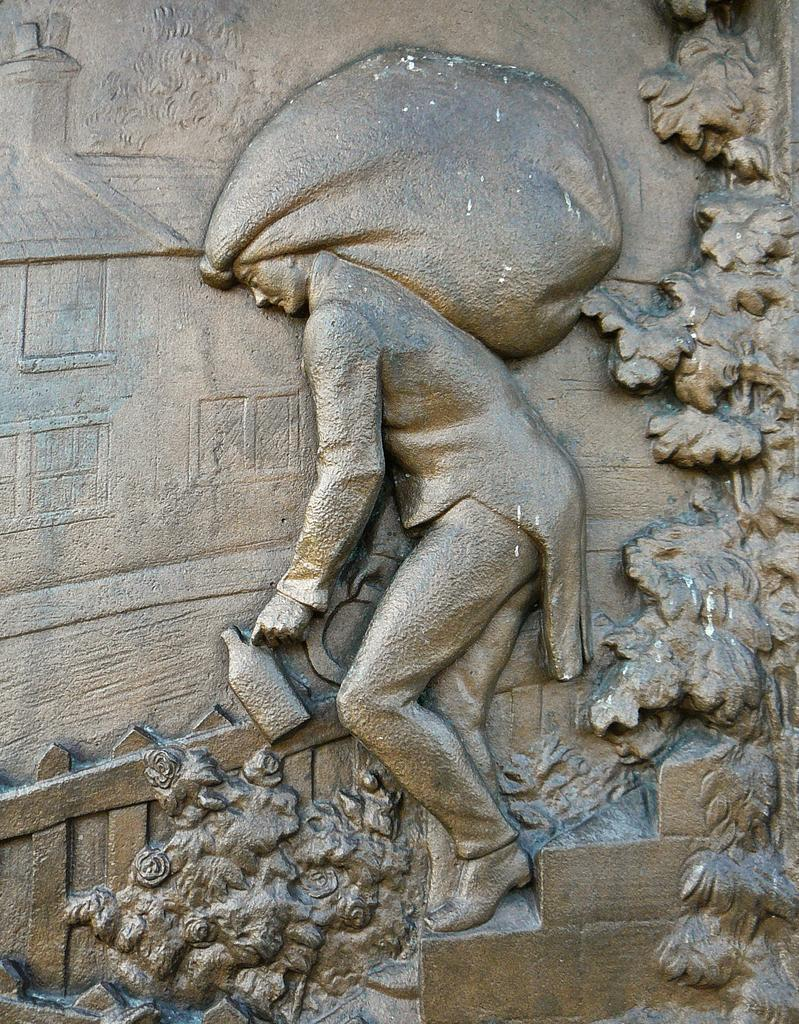What is the main subject of the image? There is a sculpture of a person in the image. What is the person in the sculpture doing? The person is holding an object. Are there any other items or objects in the image besides the sculpture? Yes, there are other objects on the wall beside the sculpture. How many babies are crawling on the floor in the image? There are no babies present in the image; it features a sculpture of a person holding an object and other objects on the wall. 